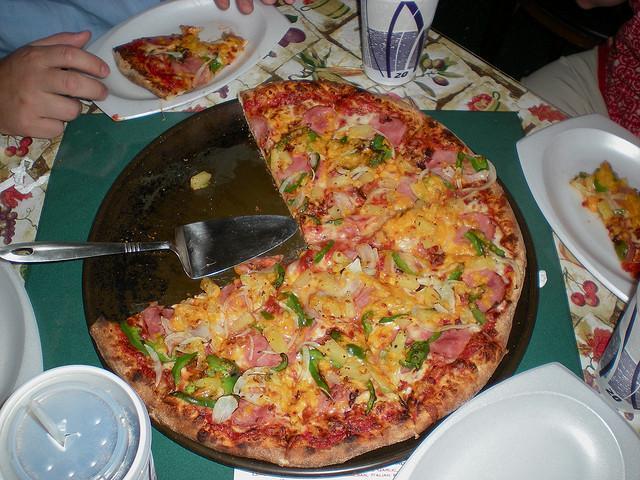How many pizzas are there?
Give a very brief answer. 3. How many people are there?
Give a very brief answer. 2. How many cups are there?
Give a very brief answer. 3. 